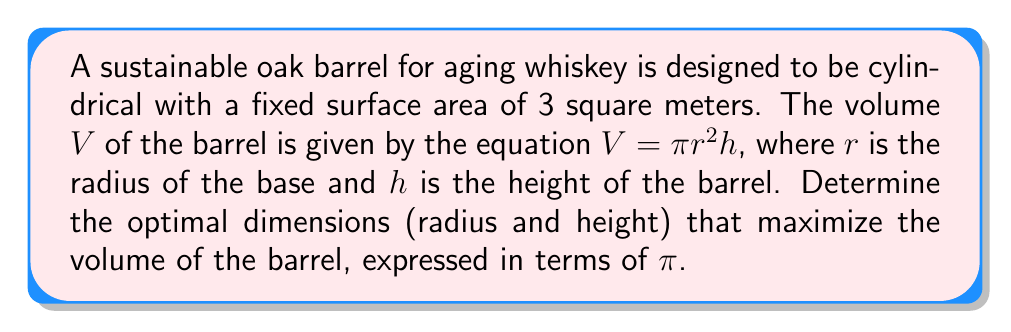Give your solution to this math problem. To solve this problem, we'll follow these steps:

1) First, we need to express the surface area of the cylinder in terms of $r$ and $h$:
   $SA = 2\pi r^2 + 2\pi rh = 3$ (given)

2) Solve this equation for $h$:
   $2\pi r^2 + 2\pi rh = 3$
   $2\pi rh = 3 - 2\pi r^2$
   $h = \frac{3 - 2\pi r^2}{2\pi r}$

3) Now, substitute this expression for $h$ into the volume equation:
   $V = \pi r^2h = \pi r^2 \cdot \frac{3 - 2\pi r^2}{2\pi r} = \frac{3r - 2\pi r^3}{2}$

4) To find the maximum volume, we need to find where the derivative of $V$ with respect to $r$ equals zero:
   $\frac{dV}{dr} = \frac{3 - 6\pi r^2}{2} = 0$

5) Solve this equation:
   $3 - 6\pi r^2 = 0$
   $6\pi r^2 = 3$
   $r^2 = \frac{1}{2\pi}$
   $r = \frac{1}{\sqrt{2\pi}}$

6) Now that we have $r$, we can find $h$ using the equation from step 2:
   $h = \frac{3 - 2\pi (\frac{1}{2\pi})}{2\pi \frac{1}{\sqrt{2\pi}}} = \frac{3 - 1}{2\pi \frac{1}{\sqrt{2\pi}}} = \frac{2\sqrt{2\pi}}{2\pi} = \frac{\sqrt{2\pi}}{\pi}$

7) The optimal volume can be calculated by substituting these values into the volume equation:
   $V = \pi r^2h = \pi \cdot (\frac{1}{\sqrt{2\pi}})^2 \cdot \frac{\sqrt{2\pi}}{\pi} = \frac{1}{\sqrt{2\pi}}$

Therefore, the optimal dimensions are:
Radius: $r = \frac{1}{\sqrt{2\pi}}$
Height: $h = \frac{\sqrt{2\pi}}{\pi}$
Volume: $V = \frac{1}{\sqrt{2\pi}}$
Answer: The optimal dimensions for the barrel are:
Radius: $r = \frac{1}{\sqrt{2\pi}}$
Height: $h = \frac{\sqrt{2\pi}}{\pi}$
Maximum Volume: $V = \frac{1}{\sqrt{2\pi}}$ cubic meters 